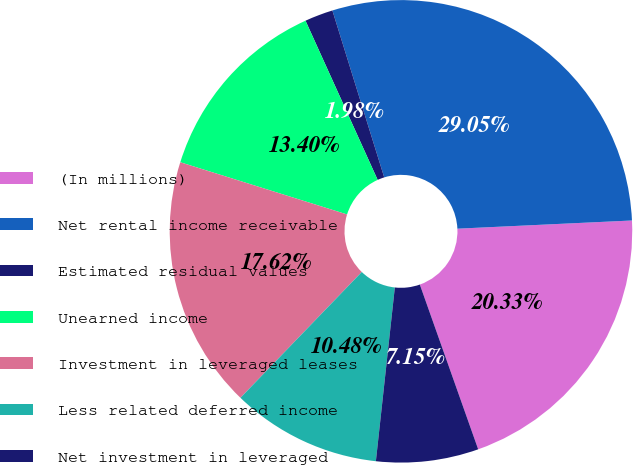Convert chart to OTSL. <chart><loc_0><loc_0><loc_500><loc_500><pie_chart><fcel>(In millions)<fcel>Net rental income receivable<fcel>Estimated residual values<fcel>Unearned income<fcel>Investment in leveraged leases<fcel>Less related deferred income<fcel>Net investment in leveraged<nl><fcel>20.33%<fcel>29.05%<fcel>1.98%<fcel>13.4%<fcel>17.62%<fcel>10.48%<fcel>7.15%<nl></chart> 